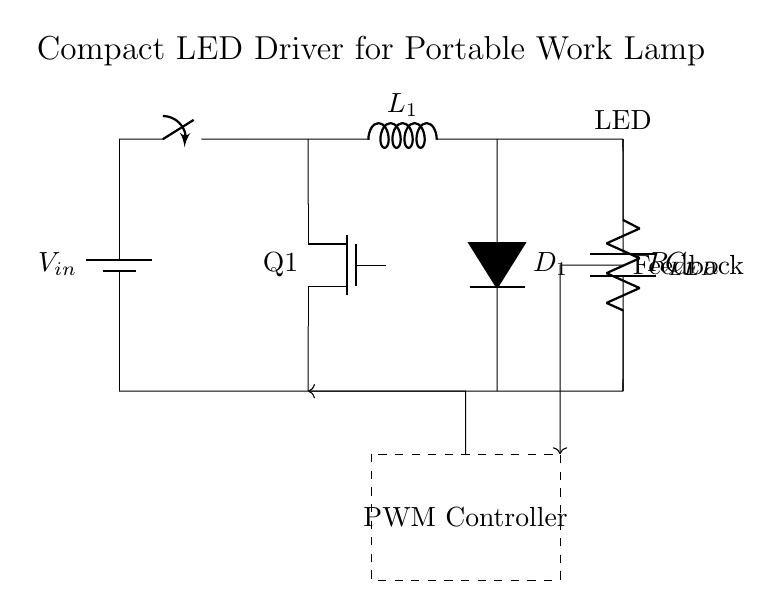What is the type of power source used in this circuit? The power source in the circuit is represented by a battery symbol, indicating it is a DC source, commonly used in portable applications.
Answer: Battery What is the main function of the PWM controller in this circuit? The PWM controller regulates the brightness of the LED by adjusting the duty cycle of the voltage sent to the LED, allowing for efficient control of LED brightness in various lighting conditions.
Answer: Brightness control Which component provides feedback for the PWM controller? The feedback is indicated by an arrow connecting the LED back to the PWM controller, allowing the controller to maintain the desired LED output based on its current state.
Answer: Feedback signal What is the role of the inductor in this circuit? The inductor, labeled L1, plays a crucial role in energy storage and smoothing out the current delivered to the LED, contributing to the buck converter operation in stepping down voltage efficiently.
Answer: Energy storage How does the MOSFET contribute to this LED driver? The MOSFET acts as a switch that controls the current flow from the input voltage to the LED based on the PWM signal, enabling precise control of the LED's operational status and efficiency in different environments.
Answer: Current control What is the purpose of the diode in this circuit? The diode, labeled D1, serves to prevent reverse current that could damage the circuit components, allowing current flow in one direction while blocking it in the opposite direction, which is essential during the PWM operation.
Answer: Prevent reverse current What is the relationship between the capacitor and LED in this driver circuit? The capacitor, labeled C1, filters and stabilizes the output voltage across the LED, ensuring a smooth and consistent current supply to the LED for optimal performance under varying input conditions.
Answer: Voltage stabilization 